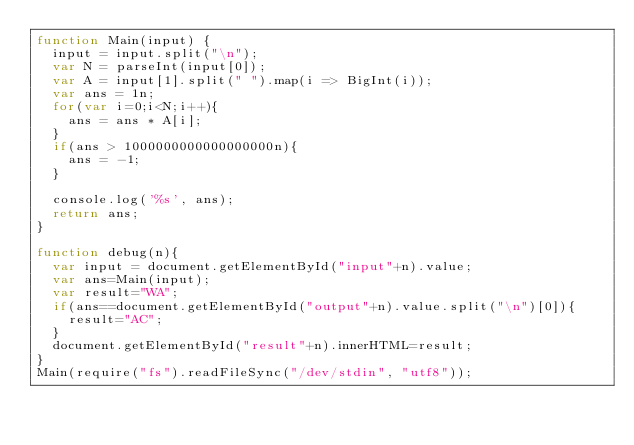<code> <loc_0><loc_0><loc_500><loc_500><_JavaScript_>function Main(input) {
  input = input.split("\n");
  var N = parseInt(input[0]);
  var A = input[1].split(" ").map(i => BigInt(i));
  var ans = 1n;
  for(var i=0;i<N;i++){
    ans = ans * A[i];
  }
  if(ans > 1000000000000000000n){
    ans = -1;
  }

  console.log('%s', ans);
  return ans;
}

function debug(n){
  var input = document.getElementById("input"+n).value;
  var ans=Main(input);
  var result="WA";
  if(ans==document.getElementById("output"+n).value.split("\n")[0]){
    result="AC";
  }
  document.getElementById("result"+n).innerHTML=result;
}
Main(require("fs").readFileSync("/dev/stdin", "utf8"));</code> 